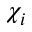Convert formula to latex. <formula><loc_0><loc_0><loc_500><loc_500>\chi _ { i }</formula> 